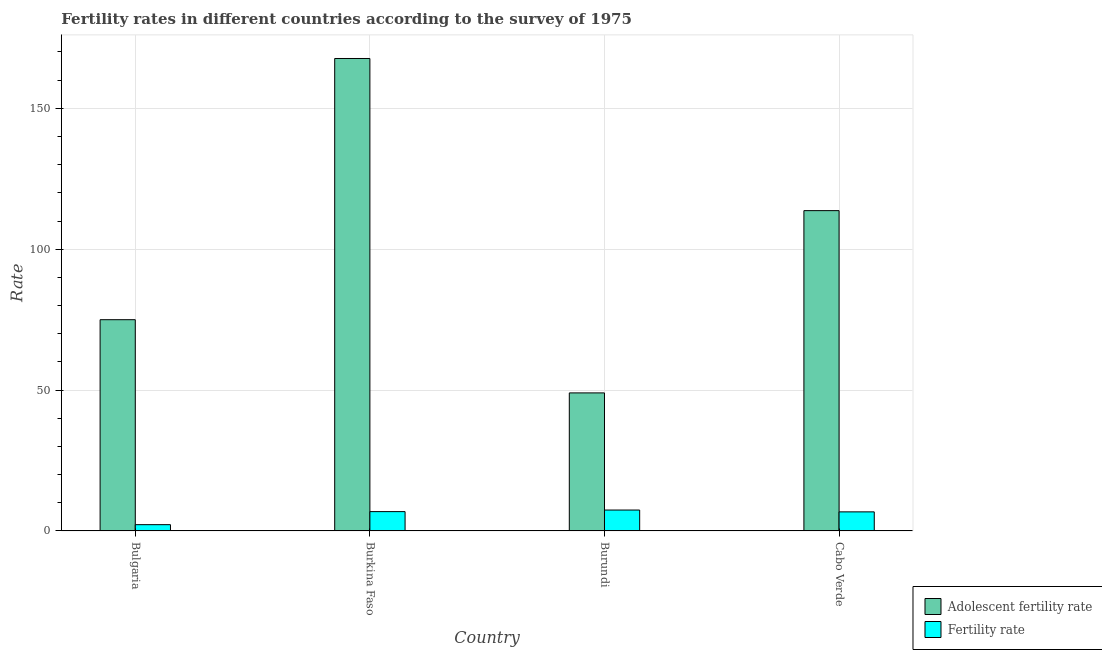How many bars are there on the 1st tick from the left?
Your answer should be compact. 2. How many bars are there on the 3rd tick from the right?
Offer a very short reply. 2. What is the label of the 3rd group of bars from the left?
Make the answer very short. Burundi. In how many cases, is the number of bars for a given country not equal to the number of legend labels?
Offer a terse response. 0. What is the fertility rate in Bulgaria?
Your answer should be compact. 2.23. Across all countries, what is the maximum adolescent fertility rate?
Keep it short and to the point. 167.67. Across all countries, what is the minimum adolescent fertility rate?
Give a very brief answer. 48.99. In which country was the adolescent fertility rate maximum?
Ensure brevity in your answer.  Burkina Faso. What is the total fertility rate in the graph?
Give a very brief answer. 23.28. What is the difference between the fertility rate in Bulgaria and that in Burkina Faso?
Your response must be concise. -4.63. What is the difference between the fertility rate in Bulgaria and the adolescent fertility rate in Burundi?
Give a very brief answer. -46.76. What is the average adolescent fertility rate per country?
Your response must be concise. 101.33. What is the difference between the fertility rate and adolescent fertility rate in Bulgaria?
Keep it short and to the point. -72.74. What is the ratio of the adolescent fertility rate in Bulgaria to that in Burkina Faso?
Give a very brief answer. 0.45. Is the adolescent fertility rate in Burkina Faso less than that in Cabo Verde?
Provide a succinct answer. No. What is the difference between the highest and the second highest fertility rate?
Offer a terse response. 0.56. What is the difference between the highest and the lowest adolescent fertility rate?
Offer a terse response. 118.68. Is the sum of the fertility rate in Burundi and Cabo Verde greater than the maximum adolescent fertility rate across all countries?
Provide a short and direct response. No. What does the 1st bar from the left in Bulgaria represents?
Your answer should be very brief. Adolescent fertility rate. What does the 1st bar from the right in Burkina Faso represents?
Make the answer very short. Fertility rate. How many bars are there?
Provide a succinct answer. 8. Are all the bars in the graph horizontal?
Provide a short and direct response. No. How many countries are there in the graph?
Give a very brief answer. 4. What is the difference between two consecutive major ticks on the Y-axis?
Make the answer very short. 50. Are the values on the major ticks of Y-axis written in scientific E-notation?
Your answer should be very brief. No. Does the graph contain any zero values?
Your answer should be compact. No. Where does the legend appear in the graph?
Your answer should be compact. Bottom right. How are the legend labels stacked?
Your answer should be compact. Vertical. What is the title of the graph?
Your answer should be very brief. Fertility rates in different countries according to the survey of 1975. What is the label or title of the X-axis?
Make the answer very short. Country. What is the label or title of the Y-axis?
Offer a very short reply. Rate. What is the Rate of Adolescent fertility rate in Bulgaria?
Your answer should be very brief. 74.97. What is the Rate in Fertility rate in Bulgaria?
Provide a succinct answer. 2.23. What is the Rate of Adolescent fertility rate in Burkina Faso?
Offer a very short reply. 167.67. What is the Rate of Fertility rate in Burkina Faso?
Your response must be concise. 6.86. What is the Rate in Adolescent fertility rate in Burundi?
Your response must be concise. 48.99. What is the Rate in Fertility rate in Burundi?
Give a very brief answer. 7.42. What is the Rate in Adolescent fertility rate in Cabo Verde?
Make the answer very short. 113.68. What is the Rate of Fertility rate in Cabo Verde?
Give a very brief answer. 6.77. Across all countries, what is the maximum Rate of Adolescent fertility rate?
Offer a terse response. 167.67. Across all countries, what is the maximum Rate of Fertility rate?
Your answer should be compact. 7.42. Across all countries, what is the minimum Rate in Adolescent fertility rate?
Your response must be concise. 48.99. Across all countries, what is the minimum Rate of Fertility rate?
Ensure brevity in your answer.  2.23. What is the total Rate of Adolescent fertility rate in the graph?
Keep it short and to the point. 405.31. What is the total Rate in Fertility rate in the graph?
Give a very brief answer. 23.28. What is the difference between the Rate in Adolescent fertility rate in Bulgaria and that in Burkina Faso?
Your answer should be compact. -92.7. What is the difference between the Rate of Fertility rate in Bulgaria and that in Burkina Faso?
Your answer should be compact. -4.63. What is the difference between the Rate in Adolescent fertility rate in Bulgaria and that in Burundi?
Provide a succinct answer. 25.98. What is the difference between the Rate in Fertility rate in Bulgaria and that in Burundi?
Make the answer very short. -5.19. What is the difference between the Rate of Adolescent fertility rate in Bulgaria and that in Cabo Verde?
Make the answer very short. -38.71. What is the difference between the Rate of Fertility rate in Bulgaria and that in Cabo Verde?
Keep it short and to the point. -4.54. What is the difference between the Rate in Adolescent fertility rate in Burkina Faso and that in Burundi?
Your answer should be very brief. 118.68. What is the difference between the Rate of Fertility rate in Burkina Faso and that in Burundi?
Keep it short and to the point. -0.56. What is the difference between the Rate of Adolescent fertility rate in Burkina Faso and that in Cabo Verde?
Your response must be concise. 54. What is the difference between the Rate in Fertility rate in Burkina Faso and that in Cabo Verde?
Make the answer very short. 0.09. What is the difference between the Rate of Adolescent fertility rate in Burundi and that in Cabo Verde?
Your answer should be very brief. -64.69. What is the difference between the Rate of Fertility rate in Burundi and that in Cabo Verde?
Your answer should be very brief. 0.65. What is the difference between the Rate in Adolescent fertility rate in Bulgaria and the Rate in Fertility rate in Burkina Faso?
Ensure brevity in your answer.  68.11. What is the difference between the Rate in Adolescent fertility rate in Bulgaria and the Rate in Fertility rate in Burundi?
Offer a very short reply. 67.55. What is the difference between the Rate in Adolescent fertility rate in Bulgaria and the Rate in Fertility rate in Cabo Verde?
Offer a terse response. 68.2. What is the difference between the Rate of Adolescent fertility rate in Burkina Faso and the Rate of Fertility rate in Burundi?
Make the answer very short. 160.26. What is the difference between the Rate in Adolescent fertility rate in Burkina Faso and the Rate in Fertility rate in Cabo Verde?
Keep it short and to the point. 160.9. What is the difference between the Rate of Adolescent fertility rate in Burundi and the Rate of Fertility rate in Cabo Verde?
Offer a terse response. 42.22. What is the average Rate of Adolescent fertility rate per country?
Provide a succinct answer. 101.33. What is the average Rate in Fertility rate per country?
Provide a short and direct response. 5.82. What is the difference between the Rate of Adolescent fertility rate and Rate of Fertility rate in Bulgaria?
Keep it short and to the point. 72.74. What is the difference between the Rate of Adolescent fertility rate and Rate of Fertility rate in Burkina Faso?
Your answer should be compact. 160.82. What is the difference between the Rate in Adolescent fertility rate and Rate in Fertility rate in Burundi?
Provide a succinct answer. 41.57. What is the difference between the Rate of Adolescent fertility rate and Rate of Fertility rate in Cabo Verde?
Offer a terse response. 106.91. What is the ratio of the Rate of Adolescent fertility rate in Bulgaria to that in Burkina Faso?
Provide a short and direct response. 0.45. What is the ratio of the Rate of Fertility rate in Bulgaria to that in Burkina Faso?
Keep it short and to the point. 0.33. What is the ratio of the Rate in Adolescent fertility rate in Bulgaria to that in Burundi?
Offer a terse response. 1.53. What is the ratio of the Rate of Fertility rate in Bulgaria to that in Burundi?
Offer a terse response. 0.3. What is the ratio of the Rate of Adolescent fertility rate in Bulgaria to that in Cabo Verde?
Your response must be concise. 0.66. What is the ratio of the Rate in Fertility rate in Bulgaria to that in Cabo Verde?
Your answer should be compact. 0.33. What is the ratio of the Rate of Adolescent fertility rate in Burkina Faso to that in Burundi?
Make the answer very short. 3.42. What is the ratio of the Rate in Fertility rate in Burkina Faso to that in Burundi?
Provide a short and direct response. 0.92. What is the ratio of the Rate in Adolescent fertility rate in Burkina Faso to that in Cabo Verde?
Your answer should be compact. 1.48. What is the ratio of the Rate in Adolescent fertility rate in Burundi to that in Cabo Verde?
Ensure brevity in your answer.  0.43. What is the ratio of the Rate in Fertility rate in Burundi to that in Cabo Verde?
Make the answer very short. 1.1. What is the difference between the highest and the second highest Rate of Adolescent fertility rate?
Make the answer very short. 54. What is the difference between the highest and the second highest Rate of Fertility rate?
Provide a short and direct response. 0.56. What is the difference between the highest and the lowest Rate of Adolescent fertility rate?
Offer a terse response. 118.68. What is the difference between the highest and the lowest Rate of Fertility rate?
Your answer should be compact. 5.19. 